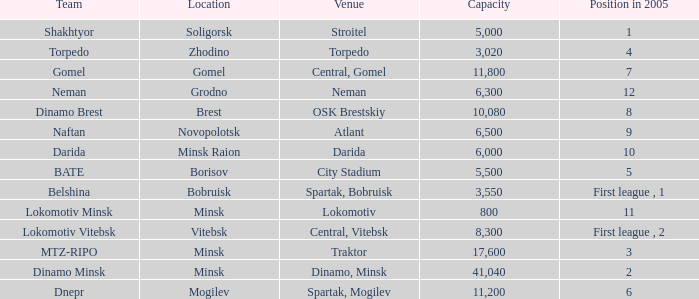Parse the full table. {'header': ['Team', 'Location', 'Venue', 'Capacity', 'Position in 2005'], 'rows': [['Shakhtyor', 'Soligorsk', 'Stroitel', '5,000', '1'], ['Torpedo', 'Zhodino', 'Torpedo', '3,020', '4'], ['Gomel', 'Gomel', 'Central, Gomel', '11,800', '7'], ['Neman', 'Grodno', 'Neman', '6,300', '12'], ['Dinamo Brest', 'Brest', 'OSK Brestskiy', '10,080', '8'], ['Naftan', 'Novopolotsk', 'Atlant', '6,500', '9'], ['Darida', 'Minsk Raion', 'Darida', '6,000', '10'], ['BATE', 'Borisov', 'City Stadium', '5,500', '5'], ['Belshina', 'Bobruisk', 'Spartak, Bobruisk', '3,550', 'First league , 1'], ['Lokomotiv Minsk', 'Minsk', 'Lokomotiv', '800', '11'], ['Lokomotiv Vitebsk', 'Vitebsk', 'Central, Vitebsk', '8,300', 'First league , 2'], ['MTZ-RIPO', 'Minsk', 'Traktor', '17,600', '3'], ['Dinamo Minsk', 'Minsk', 'Dinamo, Minsk', '41,040', '2'], ['Dnepr', 'Mogilev', 'Spartak, Mogilev', '11,200', '6']]} Can you inform me of the location that held the rank in 2005 of 8? OSK Brestskiy. 